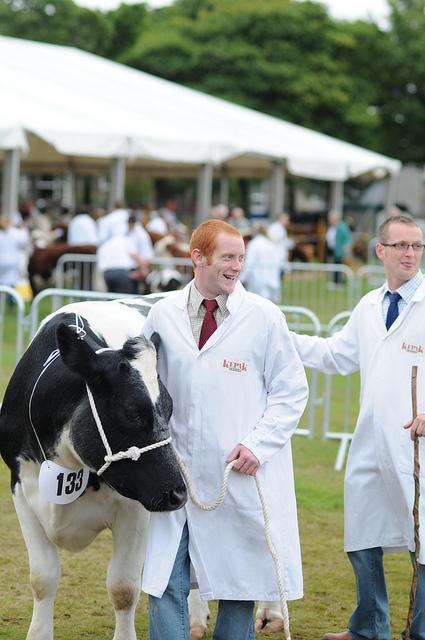How many people can you see?
Give a very brief answer. 4. 